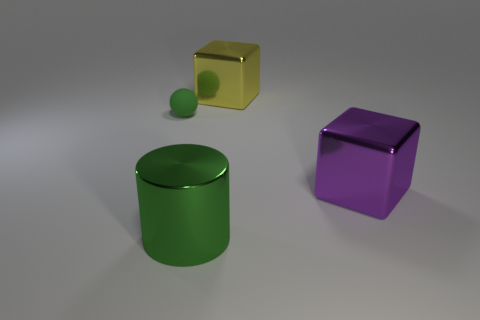There is a green rubber object that is left of the purple metal block; is it the same size as the metal cylinder?
Offer a very short reply. No. Are there fewer tiny matte spheres that are in front of the large metallic cylinder than metal things to the right of the yellow shiny cube?
Make the answer very short. Yes. Is the big cylinder the same color as the small rubber sphere?
Ensure brevity in your answer.  Yes. Are there fewer small objects behind the yellow metallic block than red cylinders?
Your answer should be very brief. No. What is the material of the large thing that is the same color as the tiny rubber sphere?
Your answer should be compact. Metal. Does the large green cylinder have the same material as the big purple block?
Ensure brevity in your answer.  Yes. What number of green balls have the same material as the yellow block?
Make the answer very short. 0. What color is the cube that is the same material as the big yellow object?
Keep it short and to the point. Purple. The big purple metallic thing is what shape?
Provide a succinct answer. Cube. What is the large object that is to the right of the yellow shiny cube made of?
Offer a very short reply. Metal. 